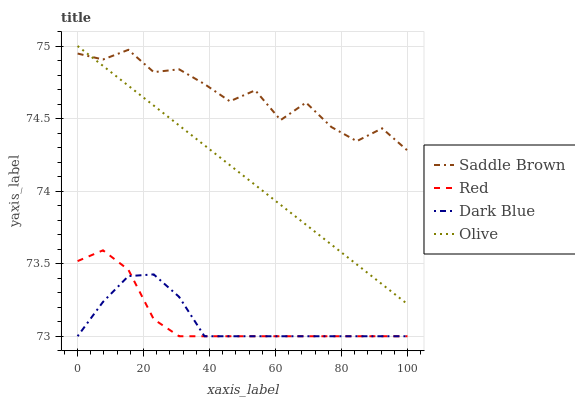Does Dark Blue have the minimum area under the curve?
Answer yes or no. Yes. Does Saddle Brown have the maximum area under the curve?
Answer yes or no. Yes. Does Saddle Brown have the minimum area under the curve?
Answer yes or no. No. Does Dark Blue have the maximum area under the curve?
Answer yes or no. No. Is Olive the smoothest?
Answer yes or no. Yes. Is Saddle Brown the roughest?
Answer yes or no. Yes. Is Dark Blue the smoothest?
Answer yes or no. No. Is Dark Blue the roughest?
Answer yes or no. No. Does Dark Blue have the lowest value?
Answer yes or no. Yes. Does Saddle Brown have the lowest value?
Answer yes or no. No. Does Olive have the highest value?
Answer yes or no. Yes. Does Saddle Brown have the highest value?
Answer yes or no. No. Is Dark Blue less than Saddle Brown?
Answer yes or no. Yes. Is Saddle Brown greater than Dark Blue?
Answer yes or no. Yes. Does Saddle Brown intersect Olive?
Answer yes or no. Yes. Is Saddle Brown less than Olive?
Answer yes or no. No. Is Saddle Brown greater than Olive?
Answer yes or no. No. Does Dark Blue intersect Saddle Brown?
Answer yes or no. No. 